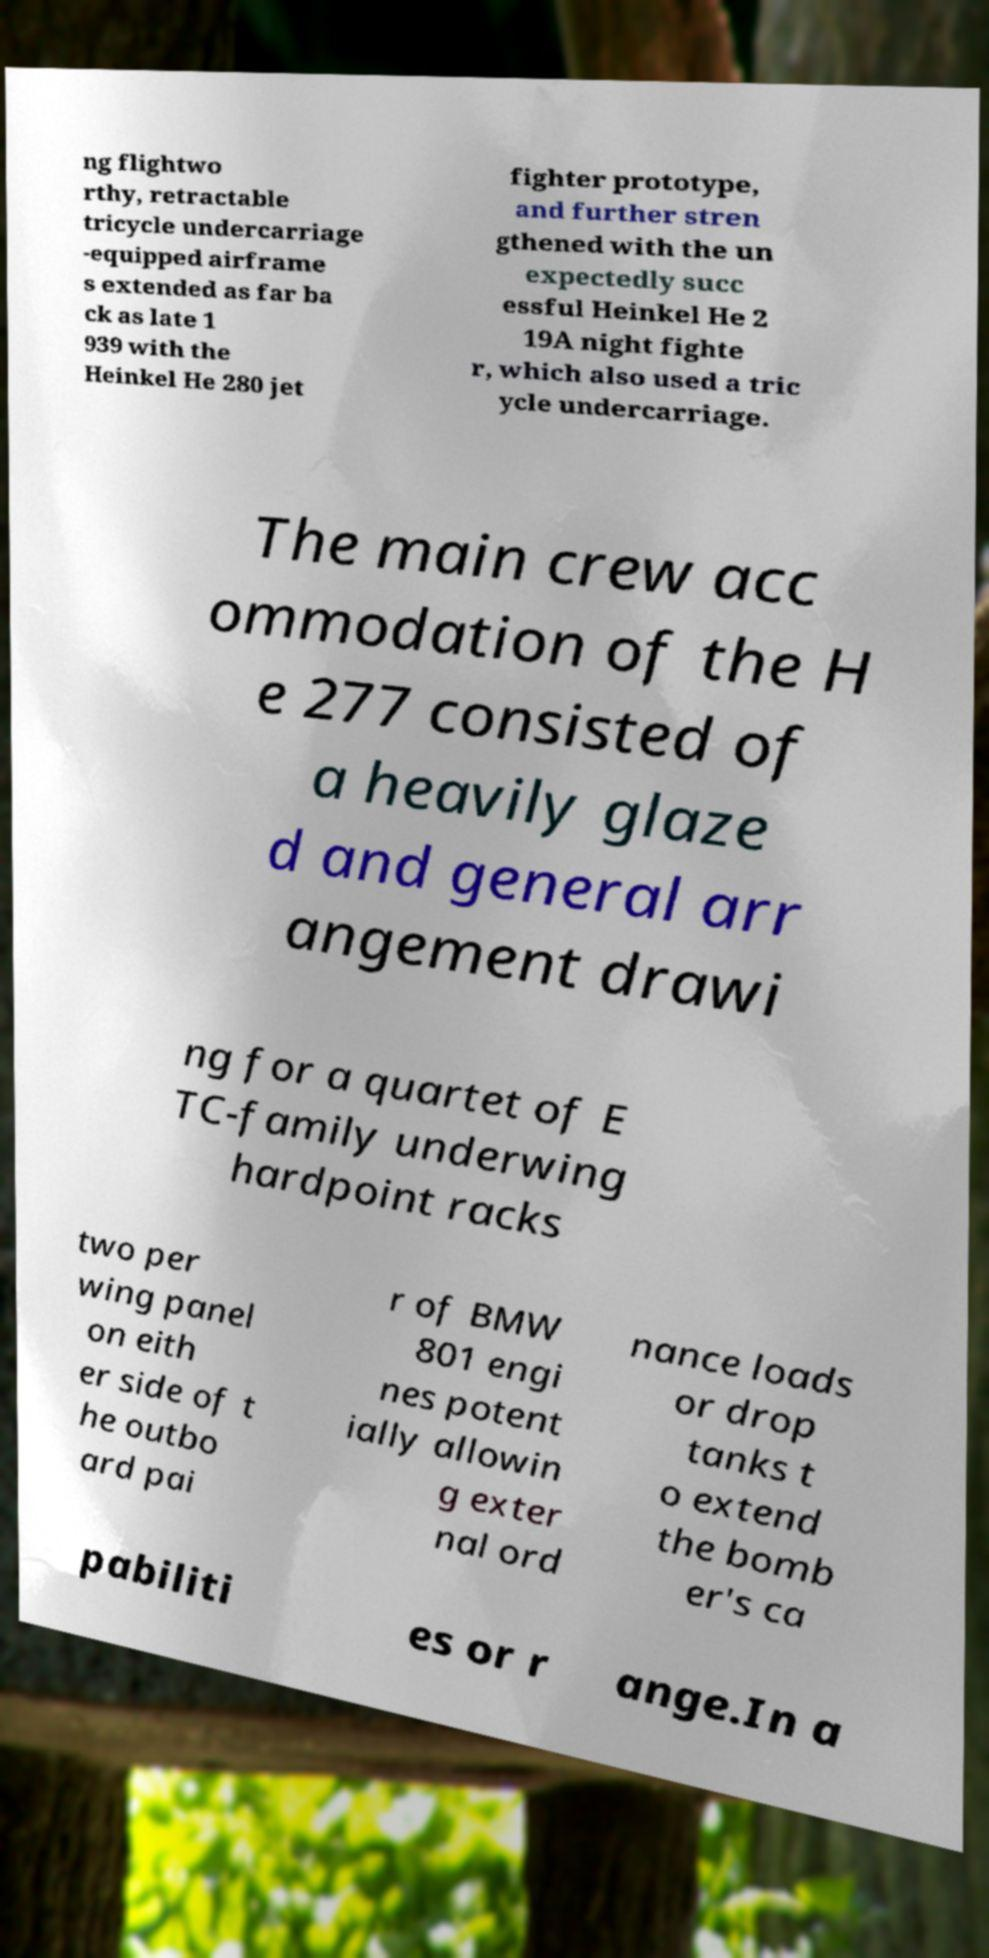For documentation purposes, I need the text within this image transcribed. Could you provide that? ng flightwo rthy, retractable tricycle undercarriage -equipped airframe s extended as far ba ck as late 1 939 with the Heinkel He 280 jet fighter prototype, and further stren gthened with the un expectedly succ essful Heinkel He 2 19A night fighte r, which also used a tric ycle undercarriage. The main crew acc ommodation of the H e 277 consisted of a heavily glaze d and general arr angement drawi ng for a quartet of E TC-family underwing hardpoint racks two per wing panel on eith er side of t he outbo ard pai r of BMW 801 engi nes potent ially allowin g exter nal ord nance loads or drop tanks t o extend the bomb er's ca pabiliti es or r ange.In a 